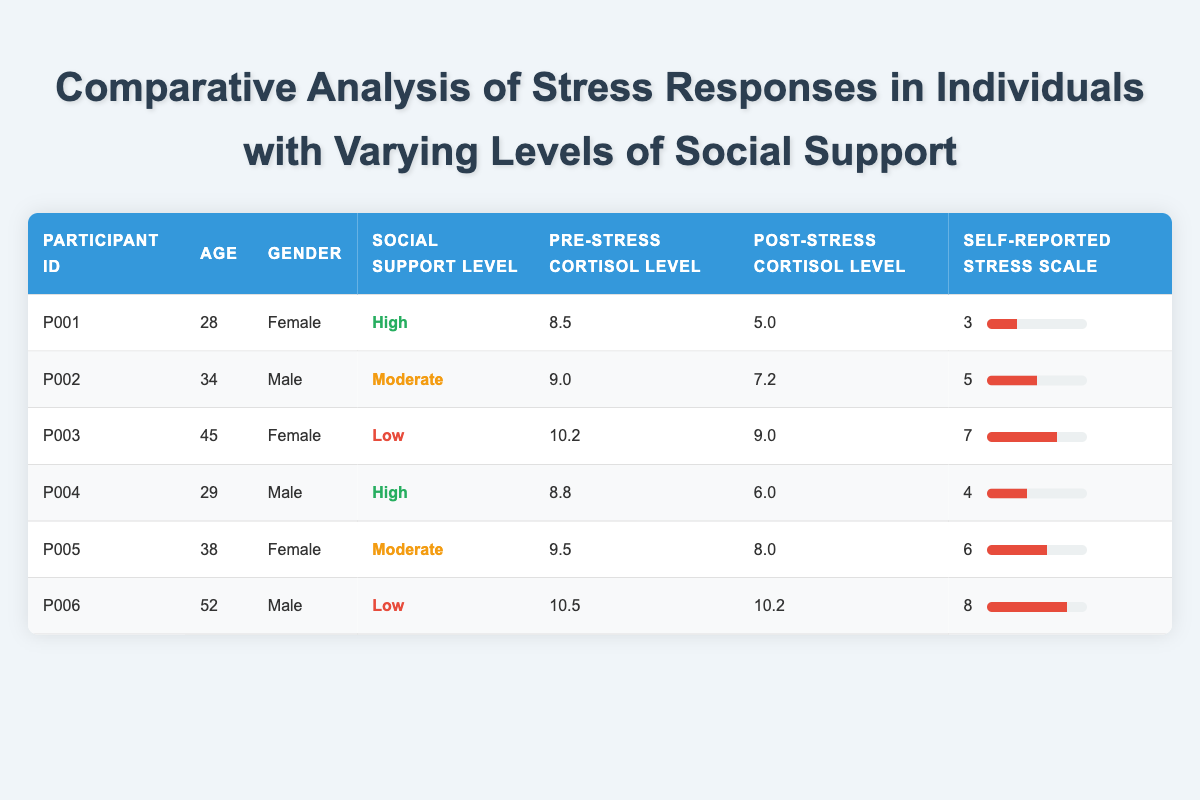What is the Social Support Level of Participant P006? The Social Support Level is located in the column corresponding to Participant P006 in the table, which shows "Low".
Answer: Low What is the Self-Reported Stress Scale value for the participant with the highest Pre-Stress Cortisol Level? First, we check the Pre-Stress Cortisol Levels for each participant: P003 has the highest at 10.2. Checking the corresponding Self-Reported Stress Scale value for P003, it is 7.
Answer: 7 How many participants have a Self-Reported Stress Scale value greater than 5? We evaluate the Self-Reported Stress Scale values for all participants: P002 (5), P003 (7), P005 (6), and P006 (8). Participants P003, P005, and P006 have values greater than 5, which totals to 3 participants.
Answer: 3 Is it true that all participants with High Social Support levels reported stress levels less than 5? Looking at the Self-Reported Stress Scale values for participants with High Social Support (P001 and P004), their values are 3 and 4, respectively, both of which are less than 5. Therefore, the statement is true.
Answer: Yes What is the average Post-Stress Cortisol Level for participants with Moderate Social Support? The Post-Stress Cortisol Levels for those with Moderate Support (P002 and P005) are 7.2 and 8.0. Their total is 15.2, and dividing by 2 gives (15.2 / 2) = 7.6 as the average.
Answer: 7.6 Which gender has the highest average Pre-Stress Cortisol Level across all participants? Calculating the average Pre-Stress Cortisol Levels for each gender: for Females (P001, P003, P005) the total is 28.2, and averaging (28.2 / 3) = 9.4; for Males (P002, P004, P006) the total is 28.3 and averaging (28.3 / 3) = 9.43. Males have the higher average.
Answer: Male How many participants reported a Self-Reported Stress Scale of 4 or less? We review the Self-Reported Stress Scale values: P001 (3), P002 (5), P003 (7), P004 (4), P005 (6), and P006 (8). Only P001 and P004 are 4 or less, leading to a total of 2 participants.
Answer: 2 What is the difference in Post-Stress Cortisol Levels between the participant with the lowest and the highest levels? The lowest Post-Stress Cortisol level is P001 at 5.0 and the highest is P006 at 10.2. The difference is calculated as 10.2 - 5.0 = 5.2.
Answer: 5.2 